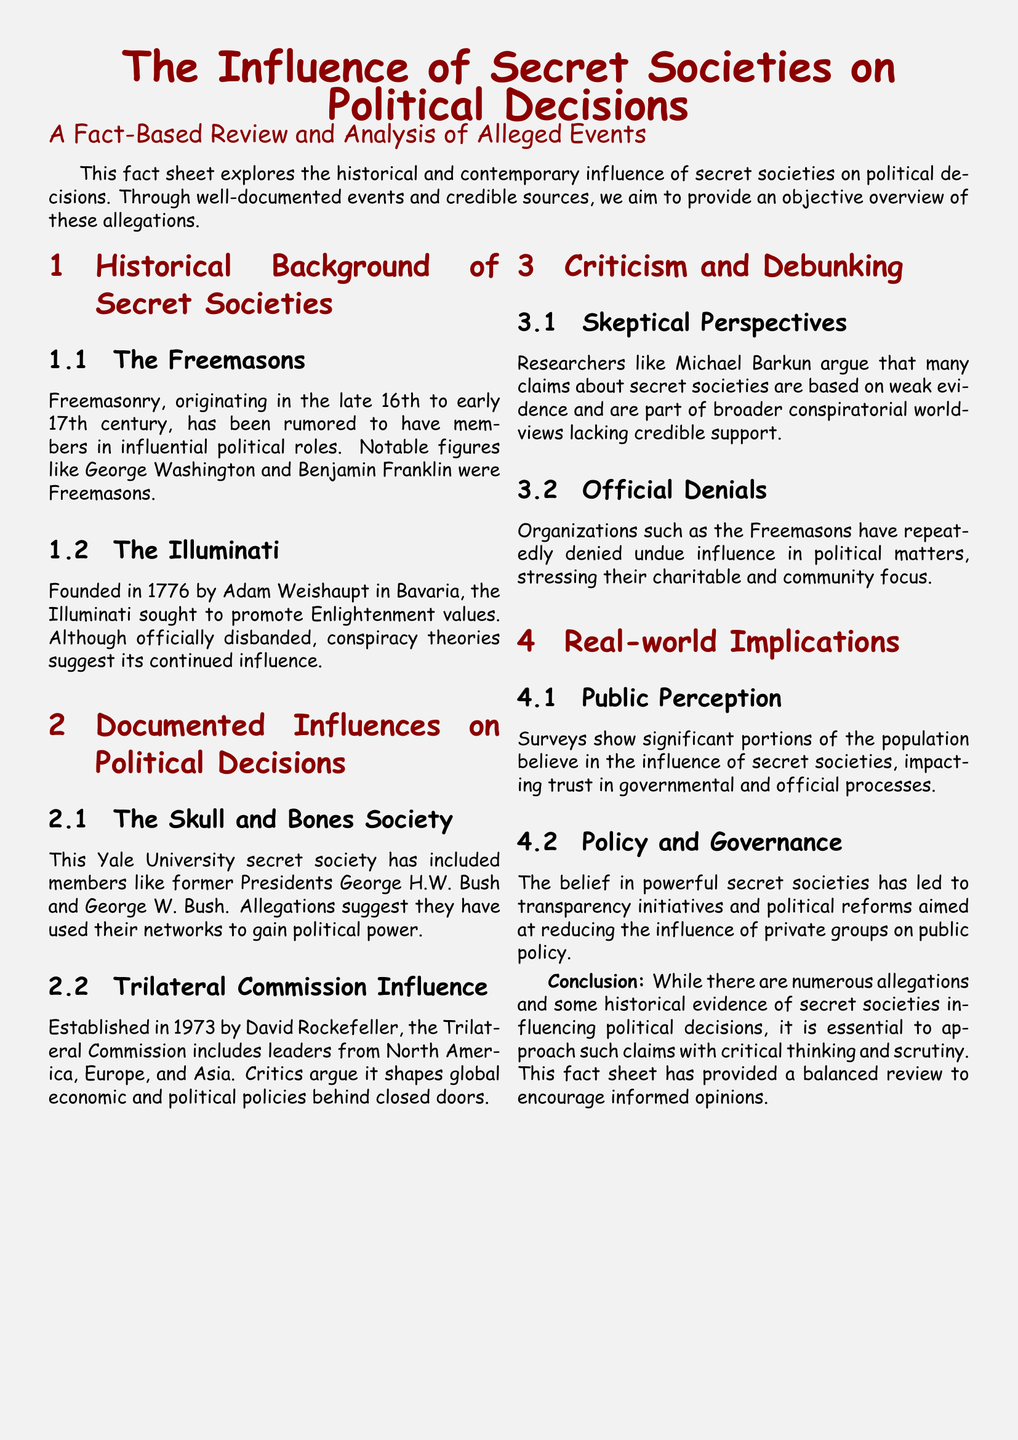What year was the Illuminati founded? The document specifies that the Illuminati was founded in 1776.
Answer: 1776 Who were notable members of the Freemasons mentioned? The document lists George Washington and Benjamin Franklin as notable Freemason members.
Answer: George Washington and Benjamin Franklin Which secret society includes former Presidents Bush? The document states that the Skull and Bones Society has included George H.W. Bush and George W. Bush.
Answer: Skull and Bones Society What organization did David Rockefeller establish? The document indicates that David Rockefeller established the Trilateral Commission in 1973.
Answer: Trilateral Commission What is a common skepticism regarding secret societies? The document notes that researchers like Michael Barkun argue that claims about secret societies are based on weak evidence.
Answer: Weak evidence What effect does the belief in secret societies have on public perception? According to the document, belief in secret societies impacts trust in governmental and official processes.
Answer: Trust in governmental processes What is the focus of organizations like the Freemasons? The document highlights that the Freemasons stress their charitable and community focus.
Answer: Charitable and community focus What type of reform is influenced by the belief in secret societies? The document states that the belief in secret societies has led to transparency initiatives and political reforms.
Answer: Transparency initiatives and political reforms 